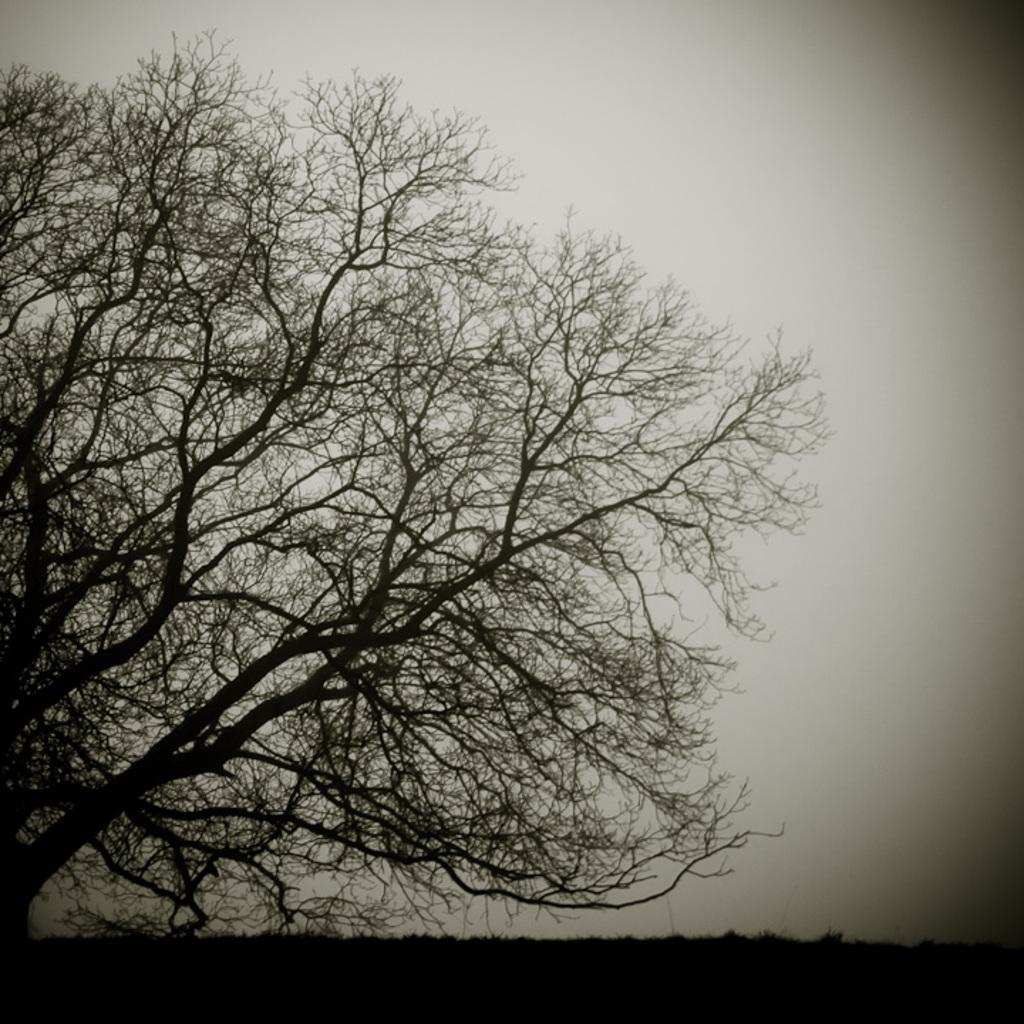What is located on the left side of the image? There is a tree on the left side of the image. What can be seen in the background of the image? The sky is visible in the background of the image. How many chickens are sitting on the window ledge in the image? There are no chickens or window ledge present in the image. 